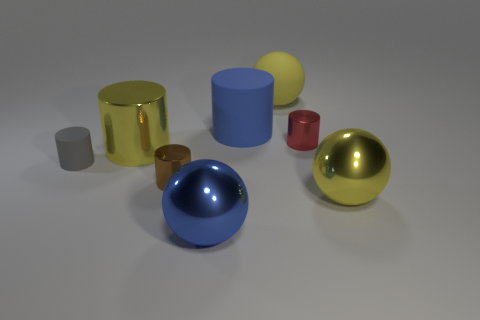Are there more tiny red cylinders than blue things?
Offer a very short reply. No. Is there a small red metallic block?
Provide a succinct answer. No. How many objects are large yellow metallic things to the right of the big yellow matte object or cylinders that are right of the big blue matte cylinder?
Offer a terse response. 2. Do the tiny rubber object and the large matte sphere have the same color?
Provide a short and direct response. No. Are there fewer small gray cylinders than big balls?
Your answer should be compact. Yes. Are there any metallic cylinders in front of the gray matte cylinder?
Keep it short and to the point. Yes. Does the tiny gray object have the same material as the brown object?
Make the answer very short. No. What is the color of the small rubber object that is the same shape as the brown metallic object?
Make the answer very short. Gray. Does the big metal thing that is to the left of the small brown cylinder have the same color as the matte ball?
Your response must be concise. Yes. The metallic thing that is the same color as the big metal cylinder is what shape?
Your answer should be very brief. Sphere. 